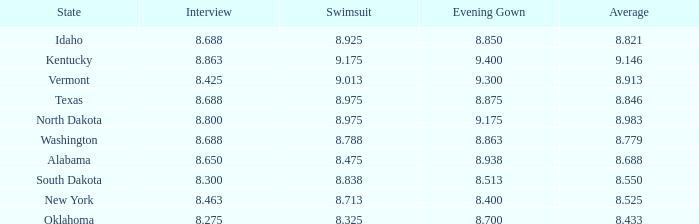What is the highest average of the contestant from Texas with an evening gown larger than 8.875? None. 